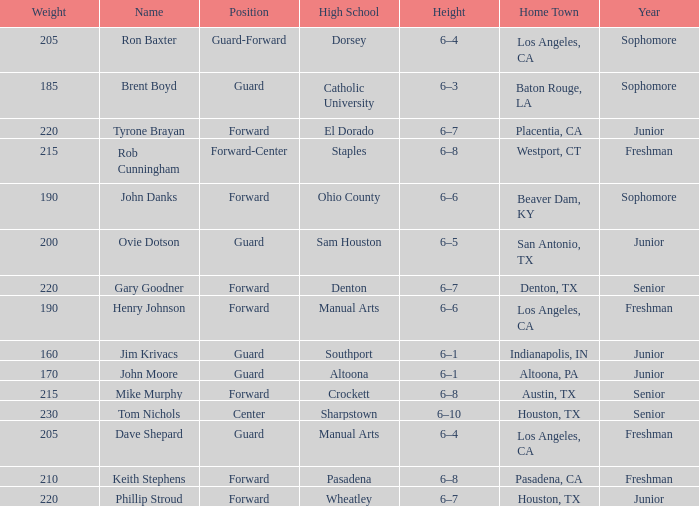What is the name featuring a year of a junior, and a high school associated with wheatley? Phillip Stroud. 